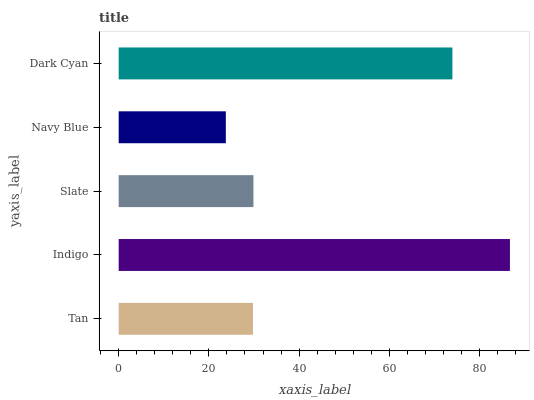Is Navy Blue the minimum?
Answer yes or no. Yes. Is Indigo the maximum?
Answer yes or no. Yes. Is Slate the minimum?
Answer yes or no. No. Is Slate the maximum?
Answer yes or no. No. Is Indigo greater than Slate?
Answer yes or no. Yes. Is Slate less than Indigo?
Answer yes or no. Yes. Is Slate greater than Indigo?
Answer yes or no. No. Is Indigo less than Slate?
Answer yes or no. No. Is Slate the high median?
Answer yes or no. Yes. Is Slate the low median?
Answer yes or no. Yes. Is Indigo the high median?
Answer yes or no. No. Is Indigo the low median?
Answer yes or no. No. 